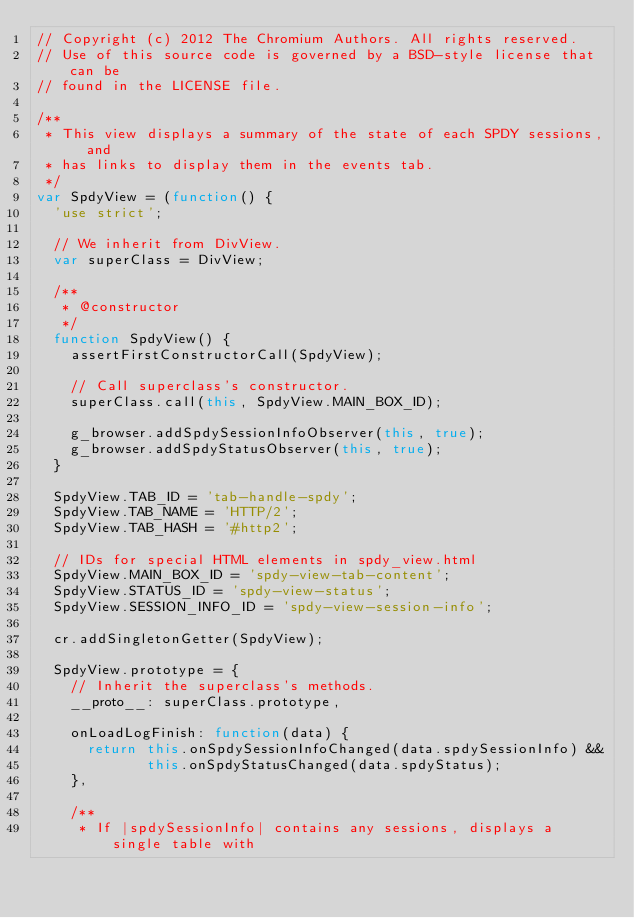Convert code to text. <code><loc_0><loc_0><loc_500><loc_500><_JavaScript_>// Copyright (c) 2012 The Chromium Authors. All rights reserved.
// Use of this source code is governed by a BSD-style license that can be
// found in the LICENSE file.

/**
 * This view displays a summary of the state of each SPDY sessions, and
 * has links to display them in the events tab.
 */
var SpdyView = (function() {
  'use strict';

  // We inherit from DivView.
  var superClass = DivView;

  /**
   * @constructor
   */
  function SpdyView() {
    assertFirstConstructorCall(SpdyView);

    // Call superclass's constructor.
    superClass.call(this, SpdyView.MAIN_BOX_ID);

    g_browser.addSpdySessionInfoObserver(this, true);
    g_browser.addSpdyStatusObserver(this, true);
  }

  SpdyView.TAB_ID = 'tab-handle-spdy';
  SpdyView.TAB_NAME = 'HTTP/2';
  SpdyView.TAB_HASH = '#http2';

  // IDs for special HTML elements in spdy_view.html
  SpdyView.MAIN_BOX_ID = 'spdy-view-tab-content';
  SpdyView.STATUS_ID = 'spdy-view-status';
  SpdyView.SESSION_INFO_ID = 'spdy-view-session-info';

  cr.addSingletonGetter(SpdyView);

  SpdyView.prototype = {
    // Inherit the superclass's methods.
    __proto__: superClass.prototype,

    onLoadLogFinish: function(data) {
      return this.onSpdySessionInfoChanged(data.spdySessionInfo) &&
             this.onSpdyStatusChanged(data.spdyStatus);
    },

    /**
     * If |spdySessionInfo| contains any sessions, displays a single table with</code> 